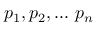Convert formula to latex. <formula><loc_0><loc_0><loc_500><loc_500>p _ { 1 } , p _ { 2 } , \dots p _ { n }</formula> 